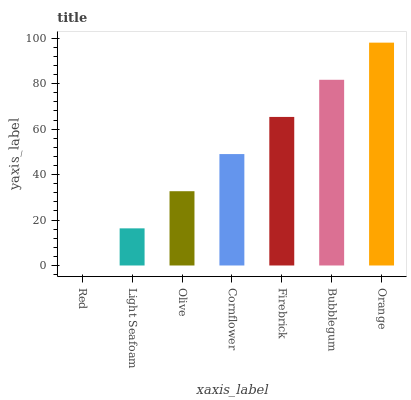Is Red the minimum?
Answer yes or no. Yes. Is Orange the maximum?
Answer yes or no. Yes. Is Light Seafoam the minimum?
Answer yes or no. No. Is Light Seafoam the maximum?
Answer yes or no. No. Is Light Seafoam greater than Red?
Answer yes or no. Yes. Is Red less than Light Seafoam?
Answer yes or no. Yes. Is Red greater than Light Seafoam?
Answer yes or no. No. Is Light Seafoam less than Red?
Answer yes or no. No. Is Cornflower the high median?
Answer yes or no. Yes. Is Cornflower the low median?
Answer yes or no. Yes. Is Orange the high median?
Answer yes or no. No. Is Orange the low median?
Answer yes or no. No. 